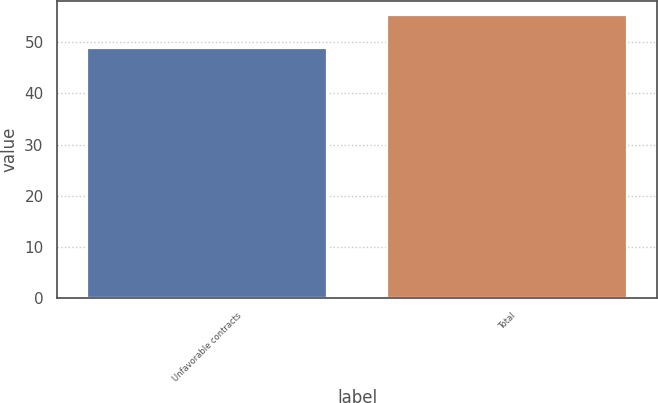Convert chart. <chart><loc_0><loc_0><loc_500><loc_500><bar_chart><fcel>Unfavorable contracts<fcel>Total<nl><fcel>49<fcel>55.4<nl></chart> 